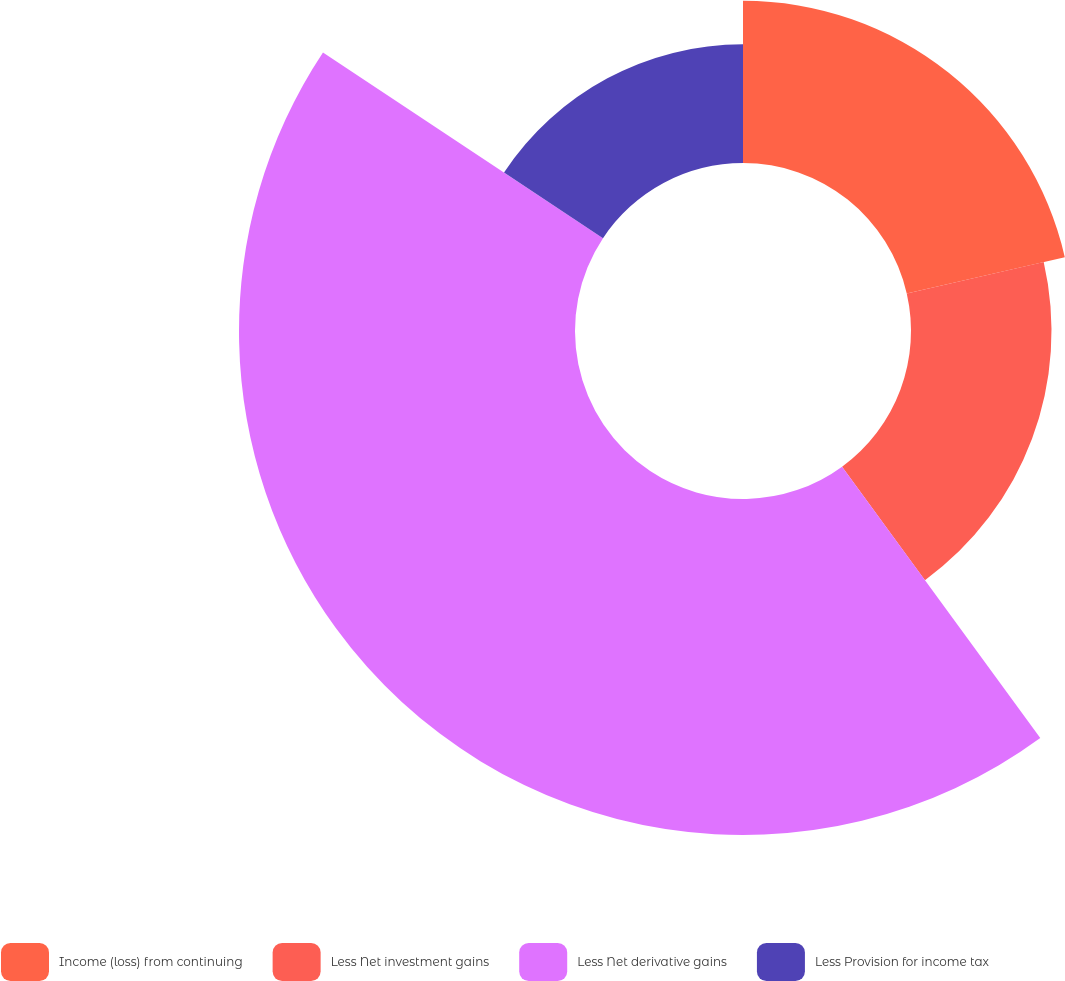Convert chart. <chart><loc_0><loc_0><loc_500><loc_500><pie_chart><fcel>Income (loss) from continuing<fcel>Less Net investment gains<fcel>Less Net derivative gains<fcel>Less Provision for income tax<nl><fcel>21.41%<fcel>18.55%<fcel>44.36%<fcel>15.68%<nl></chart> 